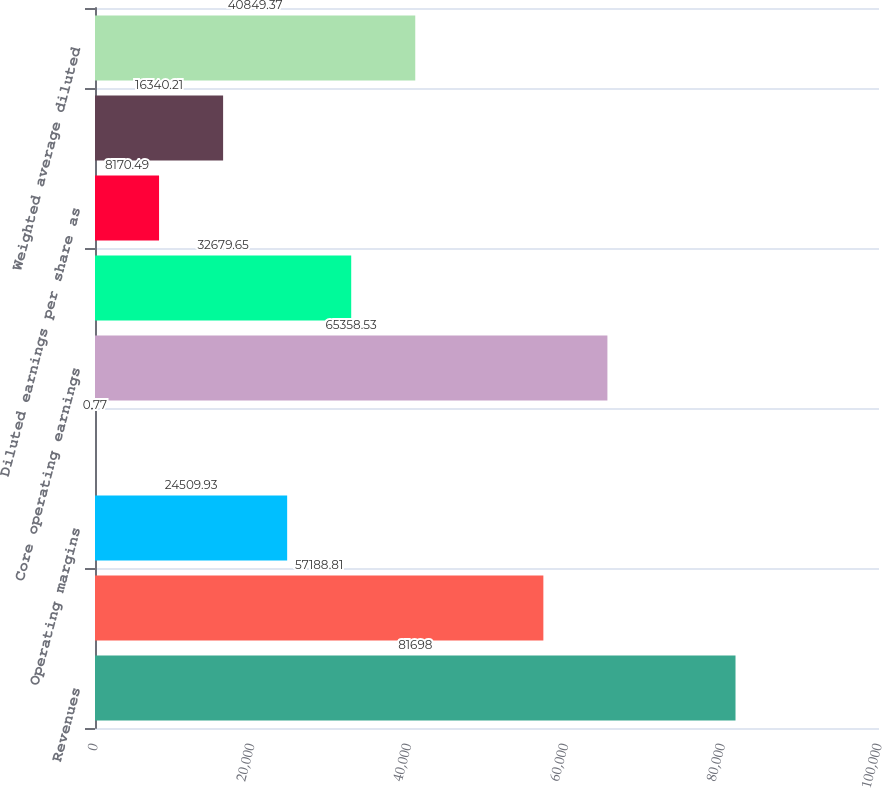Convert chart to OTSL. <chart><loc_0><loc_0><loc_500><loc_500><bar_chart><fcel>Revenues<fcel>Earnings from operations as<fcel>Operating margins<fcel>Unallocated pension and other<fcel>Core operating earnings<fcel>Core operating margins<fcel>Diluted earnings per share as<fcel>Core earnings per share<fcel>Weighted average diluted<nl><fcel>81698<fcel>57188.8<fcel>24509.9<fcel>0.77<fcel>65358.5<fcel>32679.7<fcel>8170.49<fcel>16340.2<fcel>40849.4<nl></chart> 